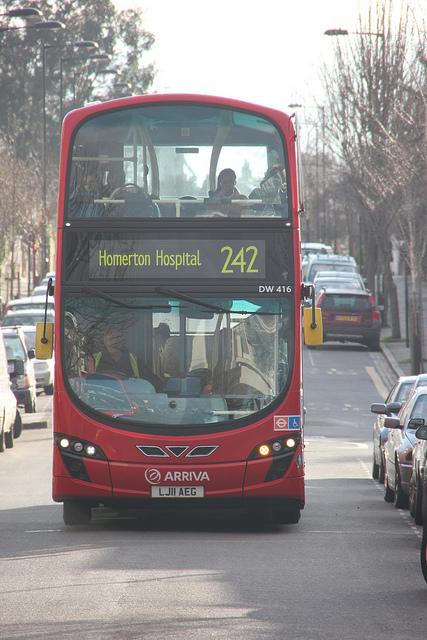Is this a double decker bus?
Answer briefly. Yes. Where is the bus going?
Short answer required. Homerton hospital. Is the bus driving away from you?
Give a very brief answer. No. 